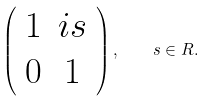<formula> <loc_0><loc_0><loc_500><loc_500>\left ( \begin{array} { c c } 1 & i s \\ 0 & 1 \end{array} \right ) , \quad s \in R .</formula> 